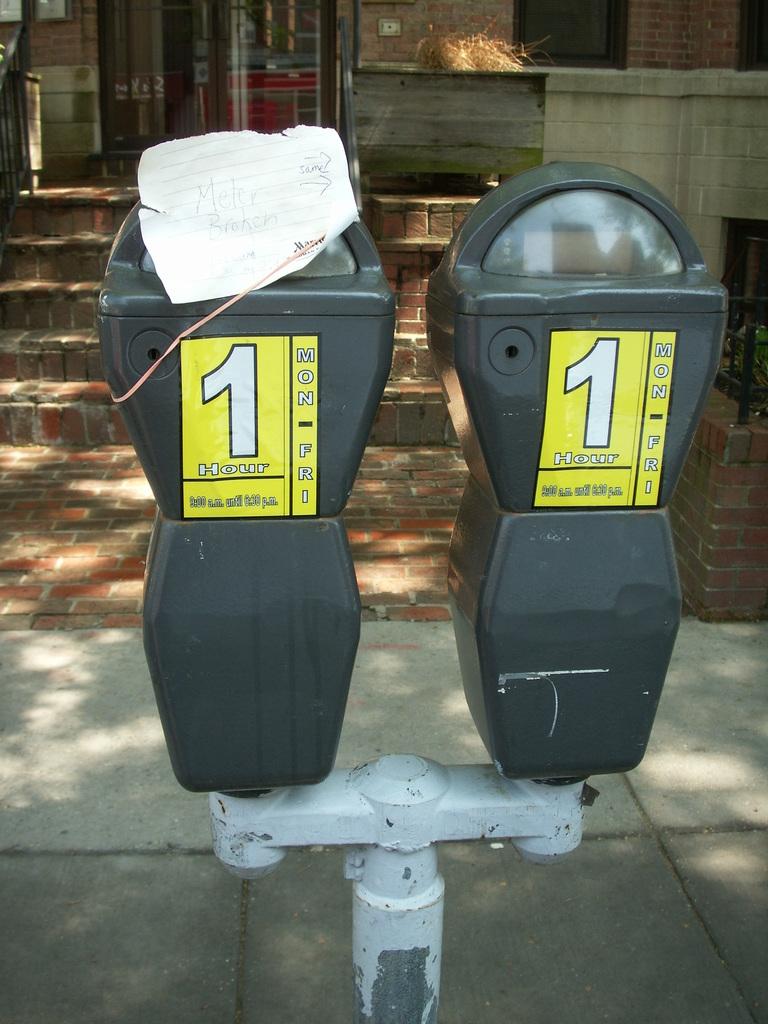How many number 1's are in this picture?
Offer a terse response. 2. What is the color of the background the ones are on?
Provide a succinct answer. Answering does not require reading text in the image. 